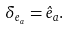Convert formula to latex. <formula><loc_0><loc_0><loc_500><loc_500>\delta _ { e _ { a } } = \hat { e } _ { a } .</formula> 